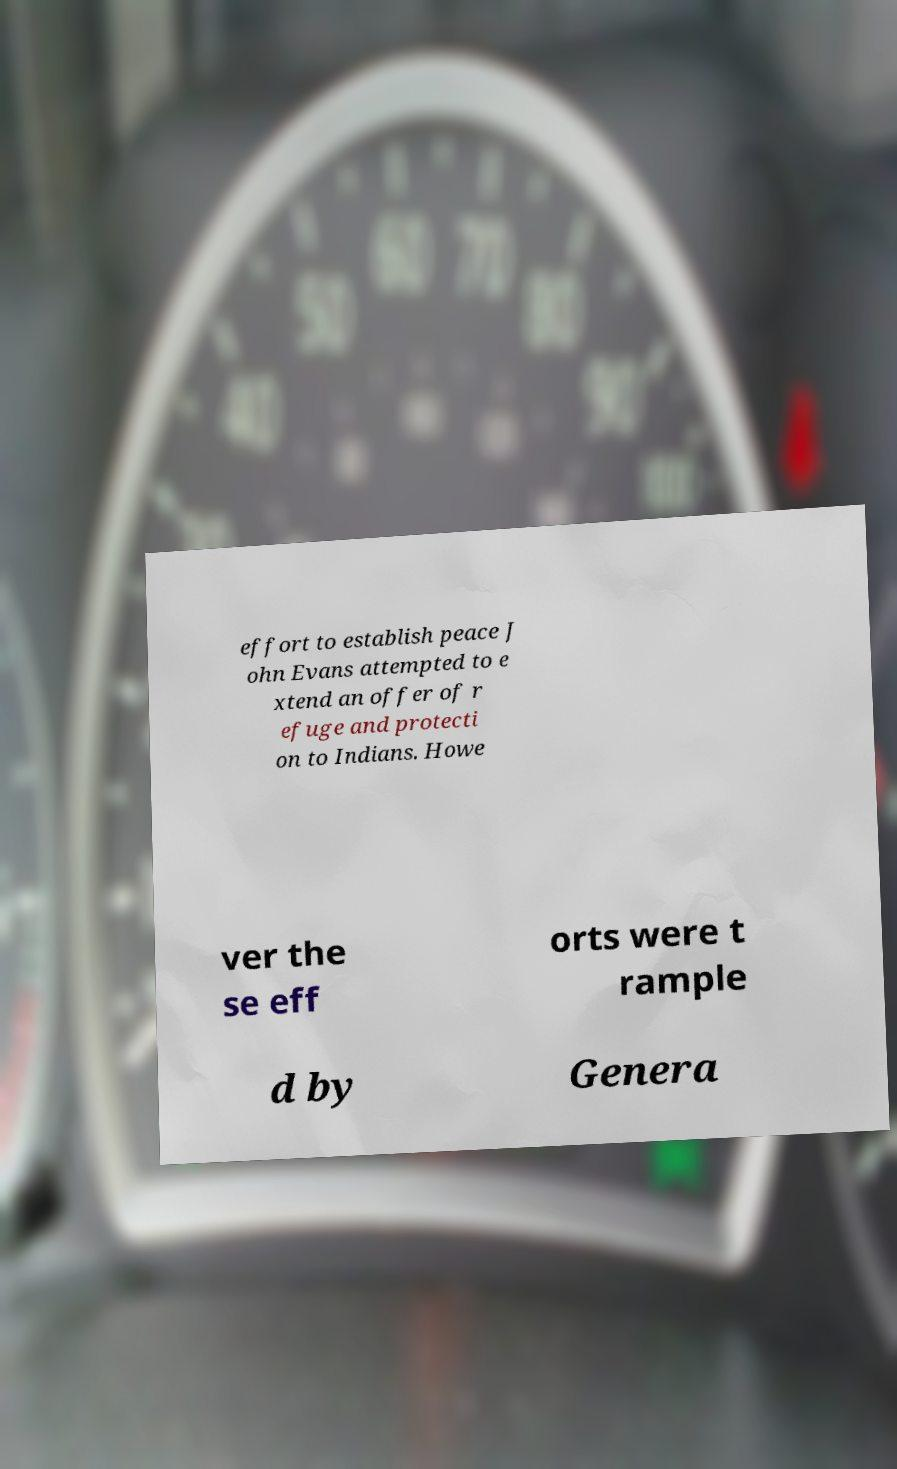Could you assist in decoding the text presented in this image and type it out clearly? effort to establish peace J ohn Evans attempted to e xtend an offer of r efuge and protecti on to Indians. Howe ver the se eff orts were t rample d by Genera 